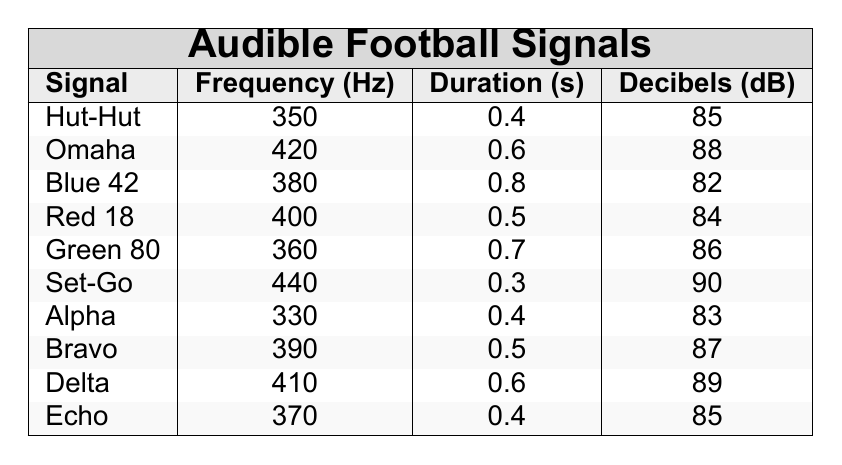What is the frequency of the "Set-Go" signal? From the table, the "Set-Go" signal has a frequency value listed under the Frequency (Hz) column. It shows a frequency of 440 Hz.
Answer: 440 Which signal has the highest decibel level? By examining the Decibels (dB) column of the table, the signal with the highest decibel level is "Set-Go" with a value of 90 dB.
Answer: Set-Go What is the average duration of all signals? To find the average duration, first sum the durations: 0.4 + 0.6 + 0.8 + 0.5 + 0.7 + 0.3 + 0.4 + 0.5 + 0.6 + 0.4 = 5.6. There are 10 signals, so the average duration is 5.6 / 10 = 0.56 seconds.
Answer: 0.56 Is the "Blue 42" signal louder than "Alpha"? The decibel levels for "Blue 42" is 82 dB, and for "Alpha" it is 83 dB. Since 82 is less than 83, "Blue 42" is not louder than "Alpha."
Answer: No Which signal has the lowest frequency, and what is that frequency? By looking through the Frequency (Hz) column, "Alpha" has the lowest frequency at 330 Hz.
Answer: Alpha, 330 What is the sum of frequencies for all signals? The sum of frequencies can be calculated as follows: 350 + 420 + 380 + 400 + 360 + 440 + 330 + 390 + 410 + 370 =  3950 Hz.
Answer: 3950 How many signals last longer than 0.5 seconds? A count of signals with durations longer than 0.5 seconds includes "Omaha" (0.6), "Blue 42" (0.8), "Green 80" (0.7), and "Delta" (0.6), resulting in 4 signals.
Answer: 4 Does the "Red 18" signal have a duration less than the average duration? The average duration was calculated to be 0.56 seconds, and "Red 18" has a duration of 0.5 seconds. Since 0.5 is less than 0.56, "Red 18" does have a shorter duration.
Answer: Yes What is the difference in decibel levels between "Echo" and "Bravo"? The decibel level for "Echo" is 85 dB and for "Bravo" it is 87 dB. The difference is calculated as 87 - 85 = 2 dB.
Answer: 2 Which signal is the loudest overall among the ones that last longer than 0.5 seconds? Among the signals longer than 0.5 seconds, we look at their decibel levels: "Omaha" (88), "Blue 42" (82), "Green 80" (86), and "Delta" (89). The loudest is "Delta" with 89 dB.
Answer: Delta 